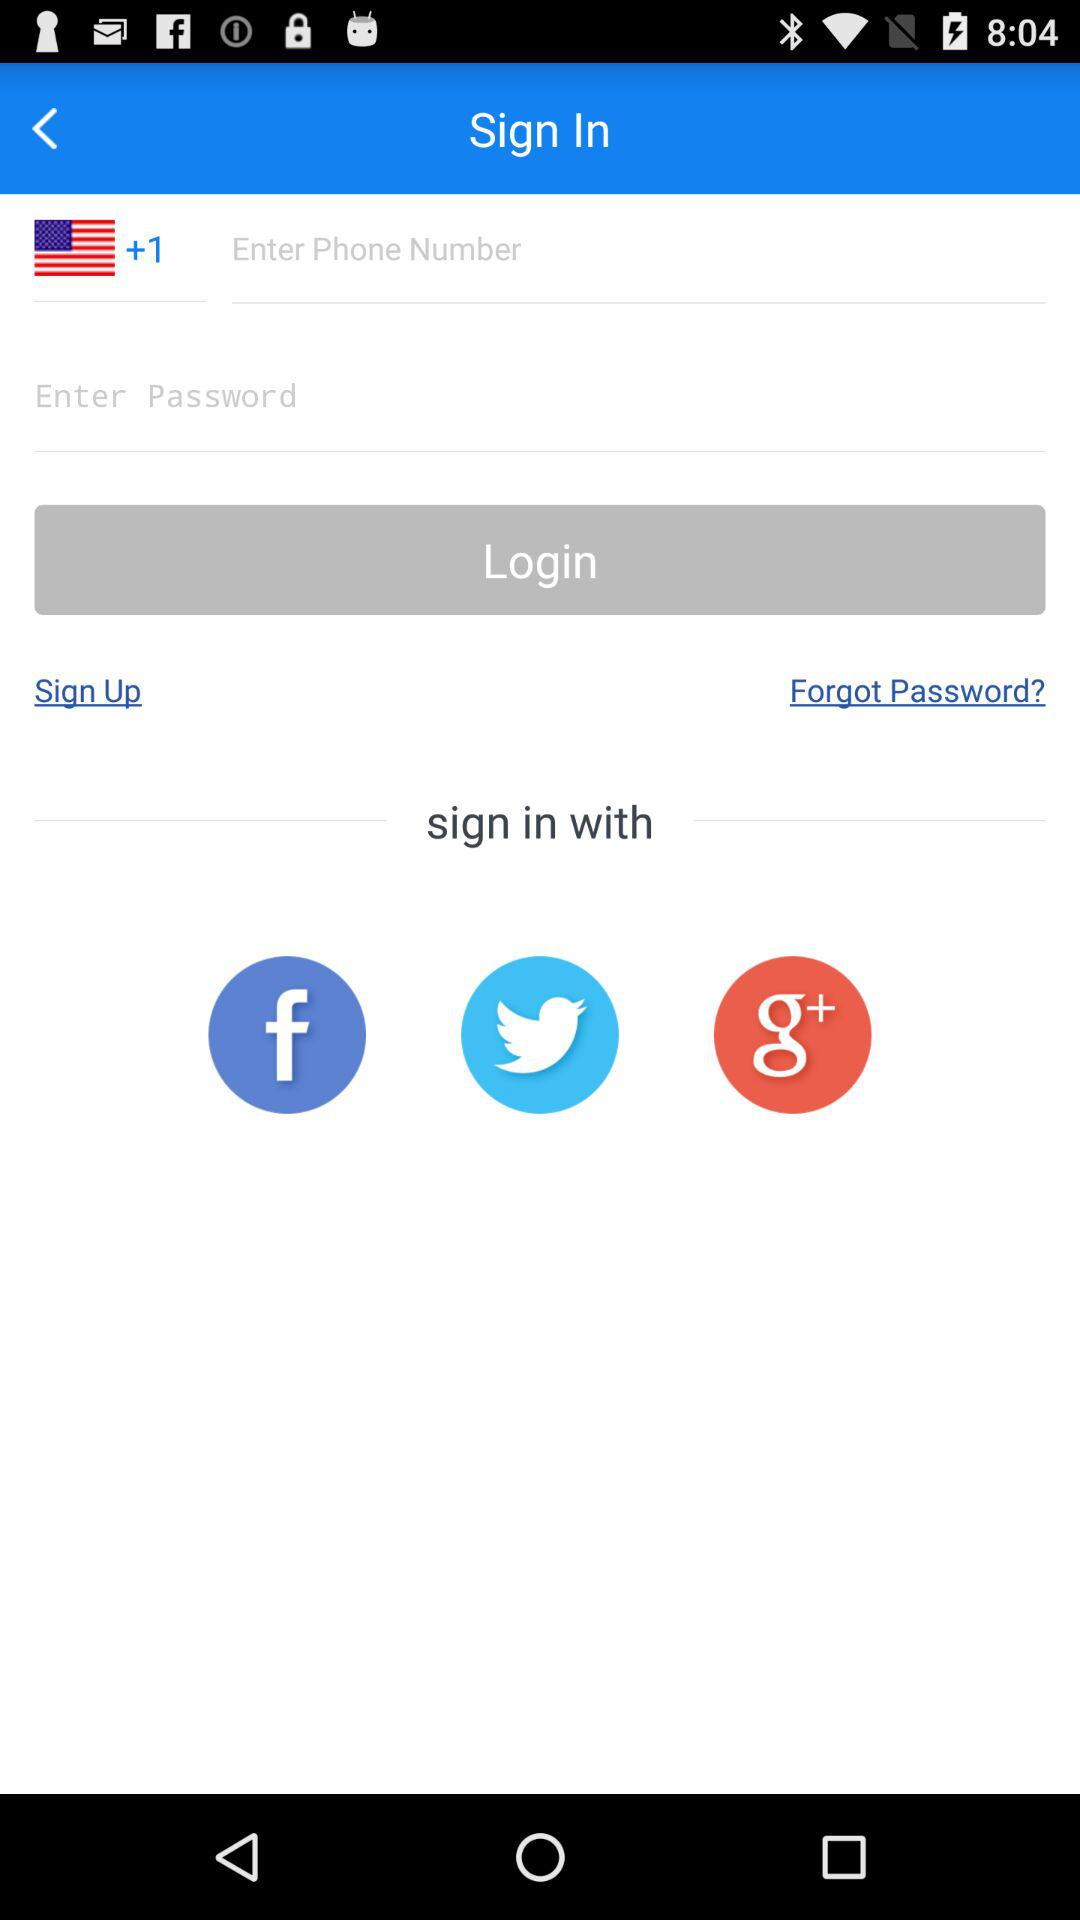How many numbers are required to create a password?
When the provided information is insufficient, respond with <no answer>. <no answer> 